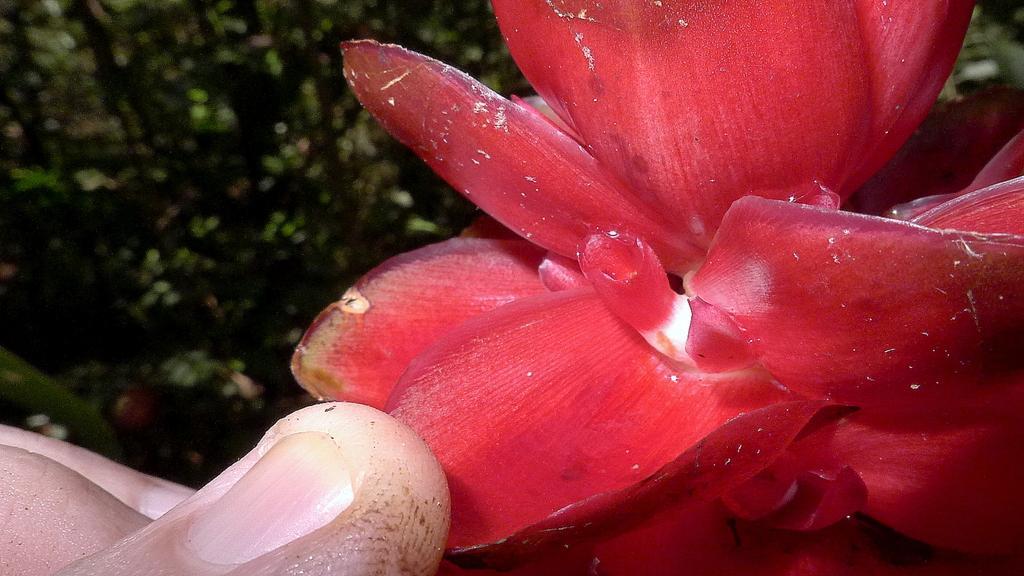Describe this image in one or two sentences. In this picture, we can see a person's hand holding a flower, and we can see the blurred background. 